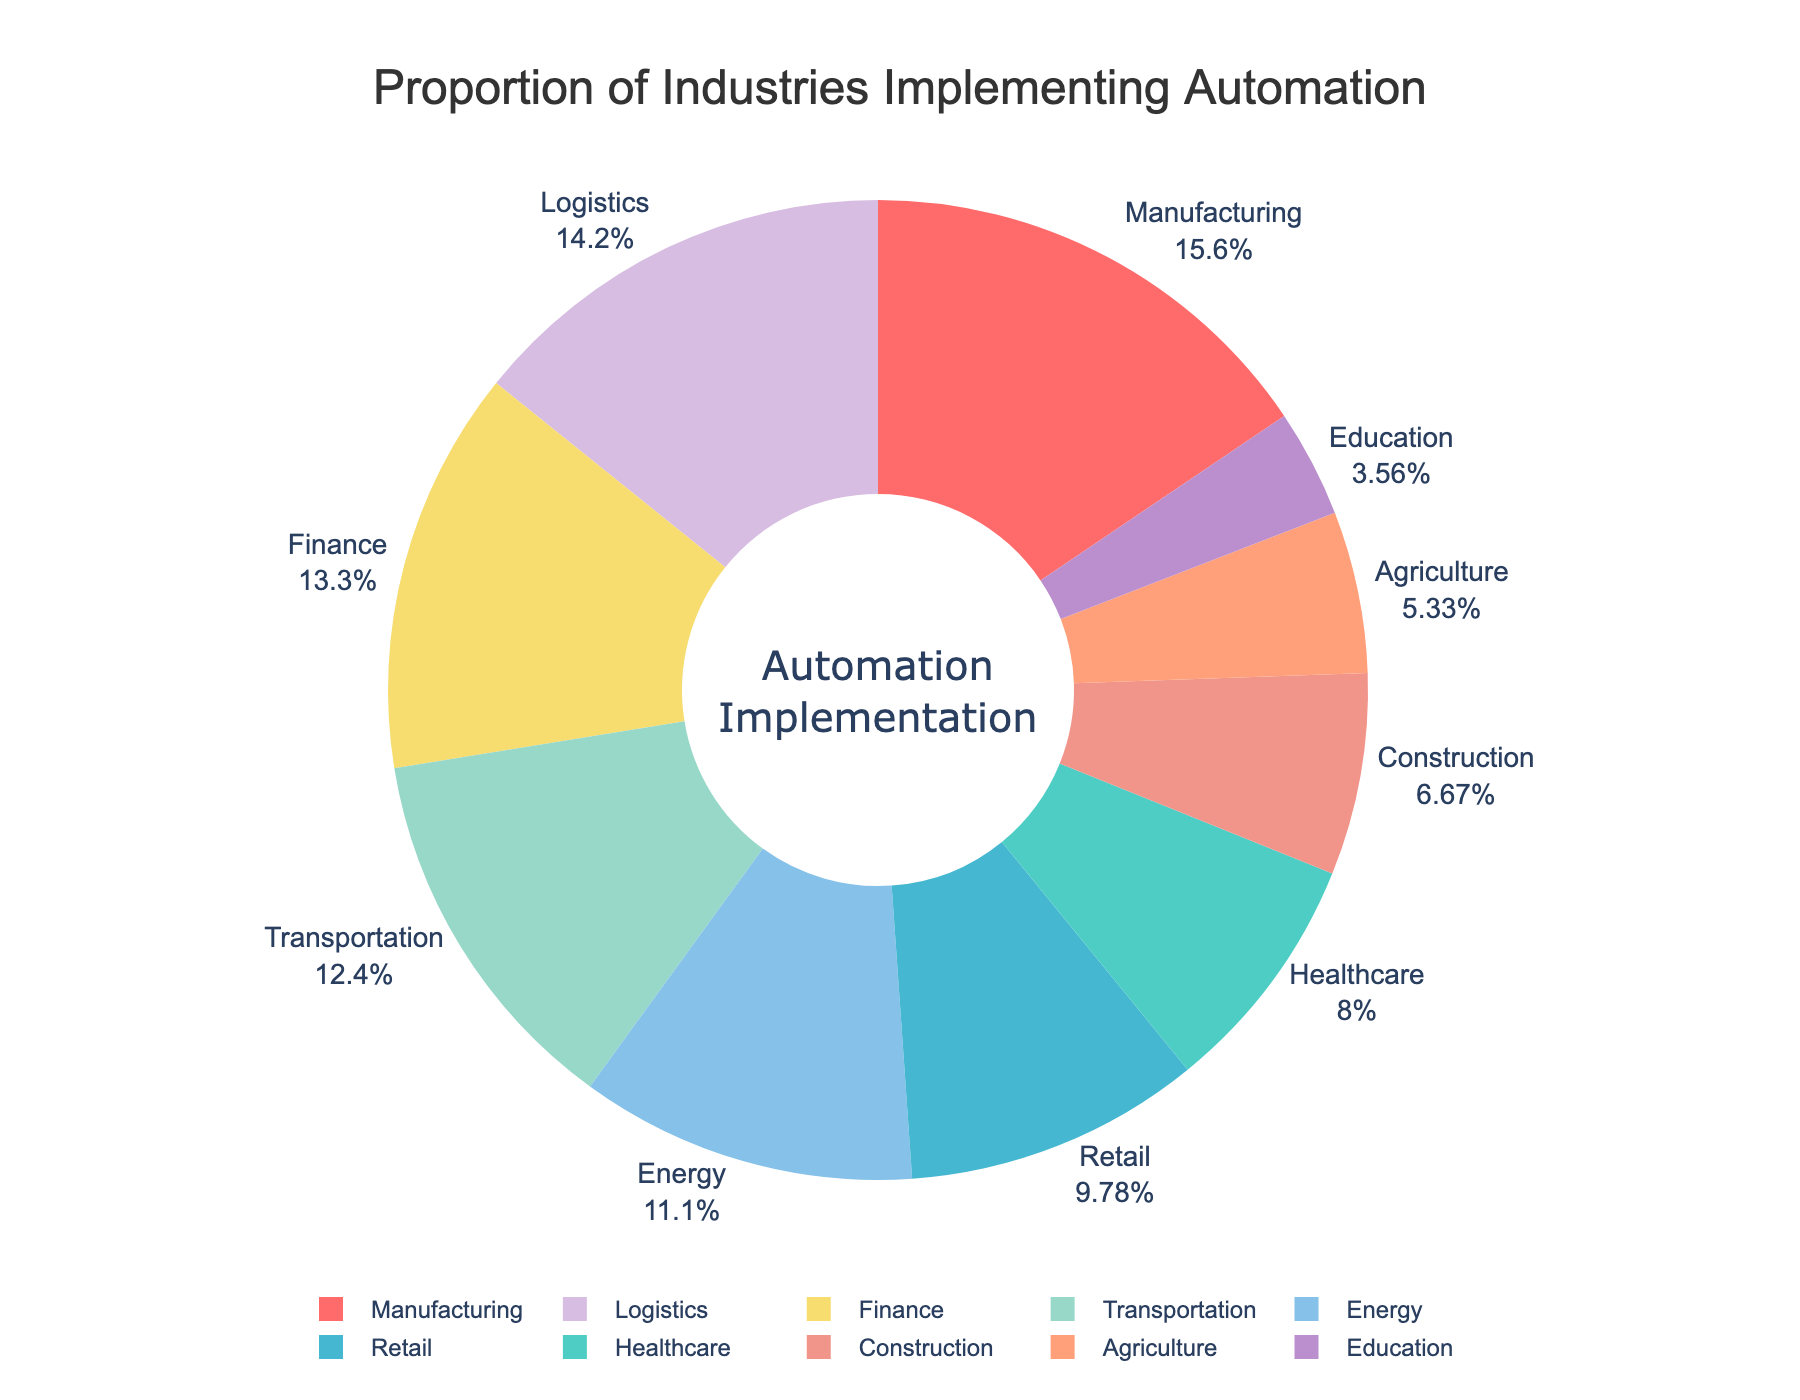Which industry has the highest proportion of automation implementation? The industry with the largest segment of the pie chart represents the highest proportion. Manufacturing has the largest segment.
Answer: Manufacturing Which industries have a higher proportion of automation implementation than Agriculture? Agriculture has 12%. Find the segments larger than 12%: Manufacturing, Healthcare, Retail, Transportation, Finance, Energy, Logistics.
Answer: Manufacturing, Healthcare, Retail, Transportation, Finance, Energy, Logistics What is the combined proportion of Finance and Logistics in automation implementation? Add the percentages for Finance and Logistics: 30% + 32% = 62%.
Answer: 62% Which industry has the smallest proportion of automation implementation? The industry with the smallest segment of the pie chart represents the smallest proportion. Education has the smallest segment.
Answer: Education How much greater is the proportion of Manufacturing compared to Education in automation implementation? Subtract the percentage of Education from Manufacturing: 35% - 8% = 27%.
Answer: 27% Among Manufacturing, Retail, and Energy, which industry has the second highest proportion of automation implementation? Compare segments for Manufacturing (35%), Retail (22%), and Energy (25%). Retail is less than Energy, so Energy is second highest.
Answer: Energy What is the total proportion of automation implementation in industries related to transportation (Transportation + Logistics)? Add the percentages for Transportation and Logistics: 28% + 32% = 60%.
Answer: 60% What is the percentage difference in automation implementation between Construction and Agriculture? Subtract Agriculture’s percentage from Construction’s: 15% - 12% = 3%.
Answer: 3% Which industry uses blue color to represent its automation implementation proportion? Look at the color of the segments and find the one in blue, which is Logistics.
Answer: Logistics What is the average proportion of automation implementation across Transportation, Finance, and Energy? Add the percentages and then divide by 3: (28% + 30% + 25%) / 3 = 83% / 3 ≈ 27.67%.
Answer: 27.67% 